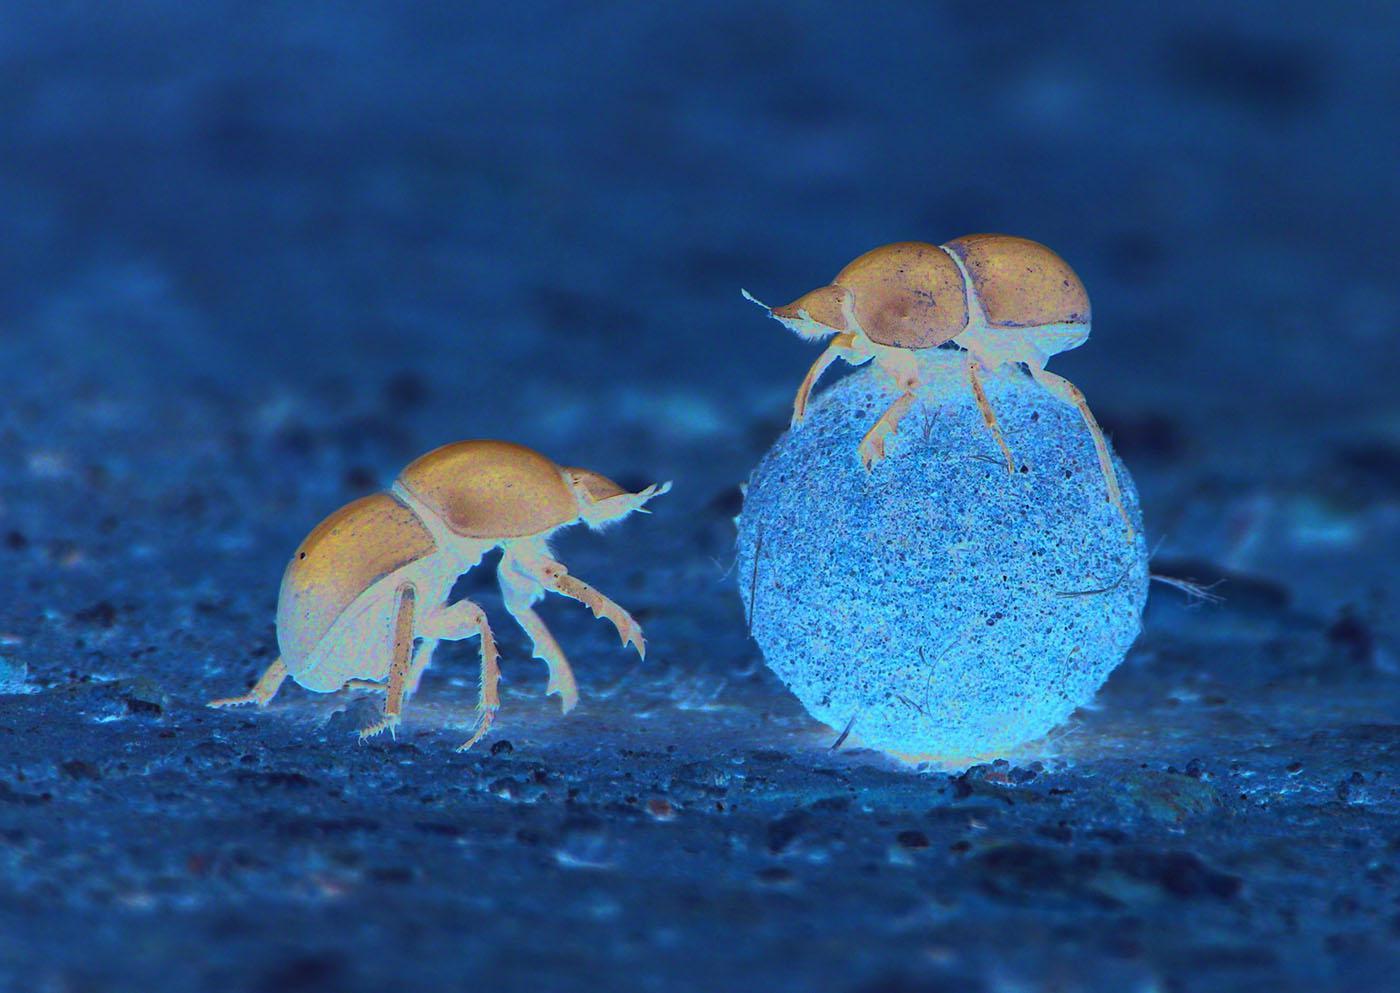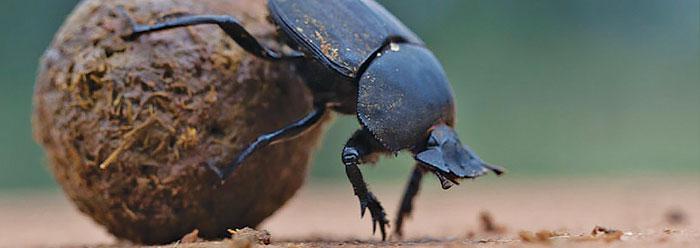The first image is the image on the left, the second image is the image on the right. For the images displayed, is the sentence "An image shows two beetles in proximity to a blue ball." factually correct? Answer yes or no. Yes. The first image is the image on the left, the second image is the image on the right. For the images shown, is this caption "The ball in one of the images is not brown." true? Answer yes or no. Yes. 